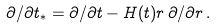<formula> <loc_0><loc_0><loc_500><loc_500>\partial / \partial t _ { * } = \partial / \partial t - H ( t ) r \, \partial / \partial r \, .</formula> 